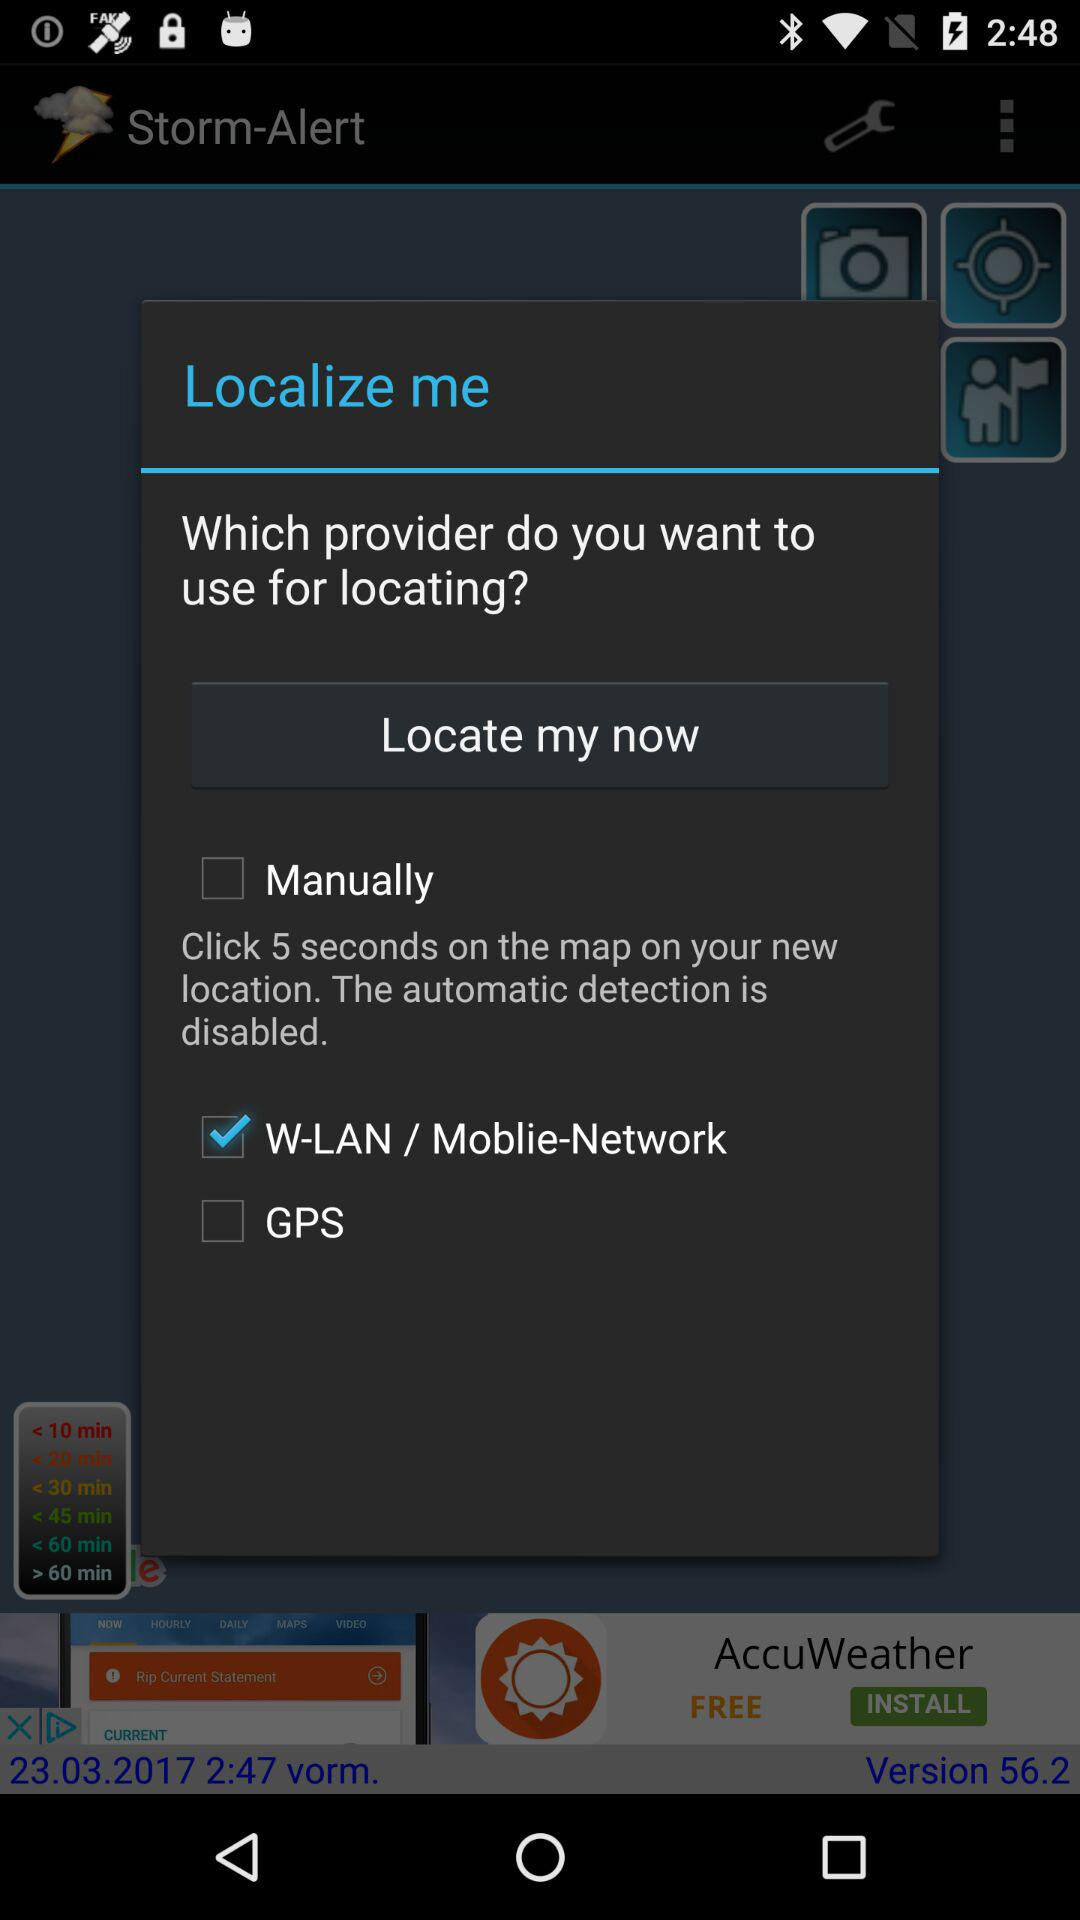Is "GPS" checked or not? "GPS" is not checked. 